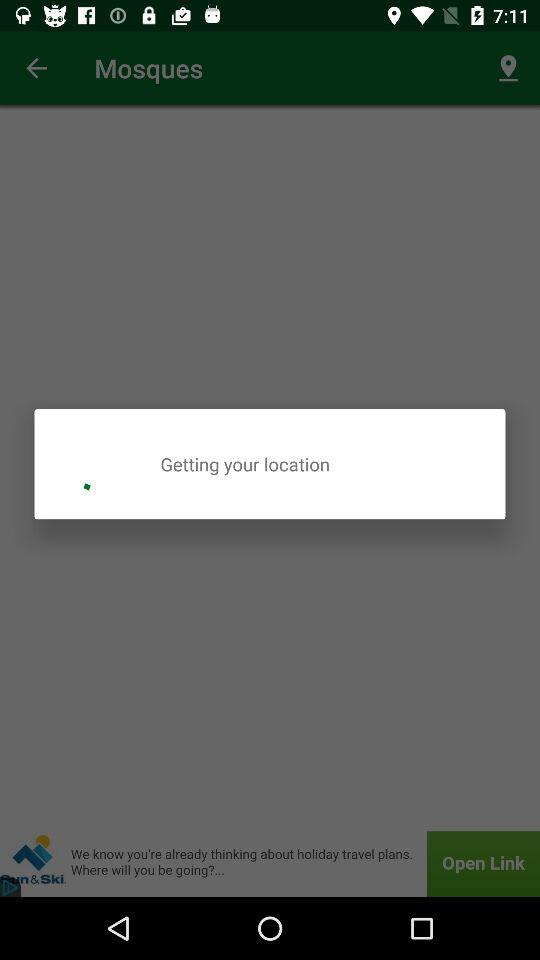What is the name of the application? The name of the application is "Muslim Pro". 